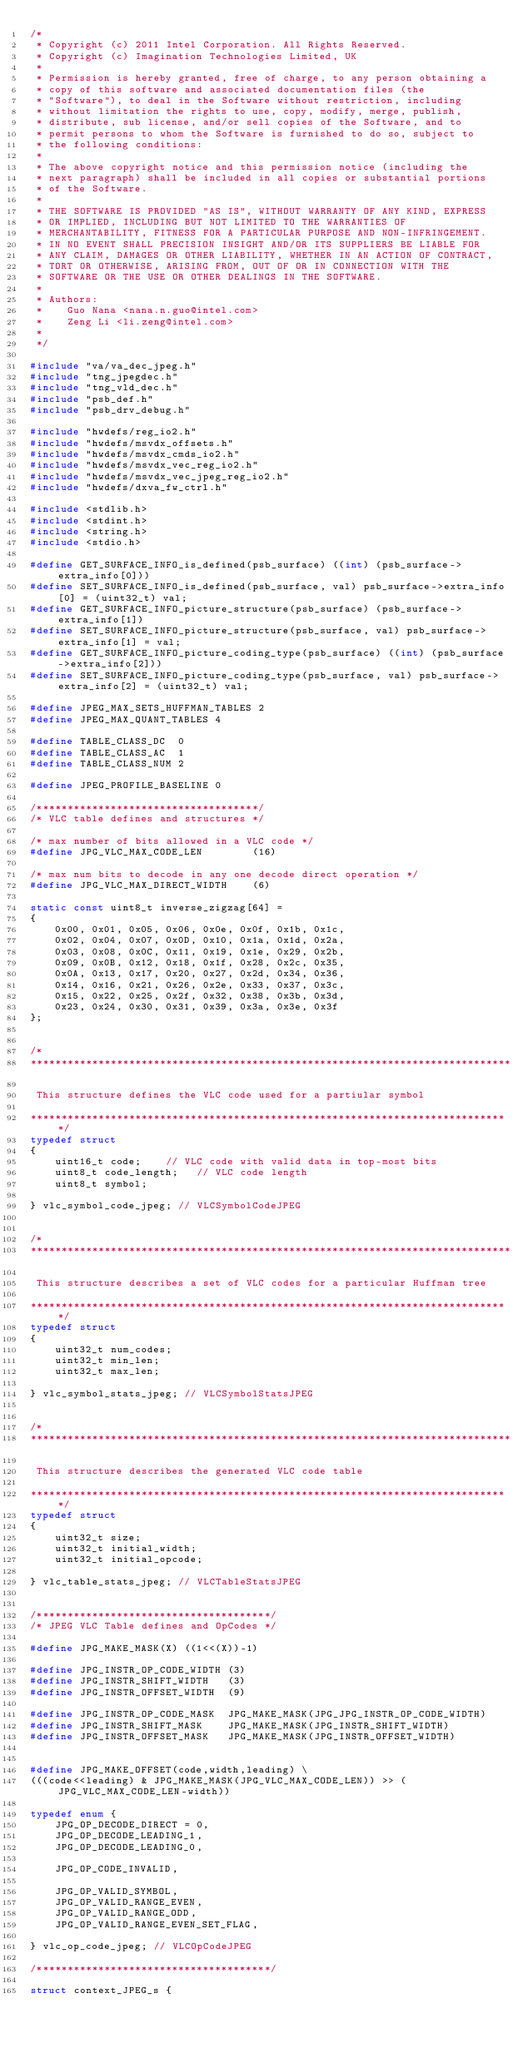Convert code to text. <code><loc_0><loc_0><loc_500><loc_500><_C_>/*
 * Copyright (c) 2011 Intel Corporation. All Rights Reserved.
 * Copyright (c) Imagination Technologies Limited, UK
 *
 * Permission is hereby granted, free of charge, to any person obtaining a
 * copy of this software and associated documentation files (the
 * "Software"), to deal in the Software without restriction, including
 * without limitation the rights to use, copy, modify, merge, publish,
 * distribute, sub license, and/or sell copies of the Software, and to
 * permit persons to whom the Software is furnished to do so, subject to
 * the following conditions:
 *
 * The above copyright notice and this permission notice (including the
 * next paragraph) shall be included in all copies or substantial portions
 * of the Software.
 *
 * THE SOFTWARE IS PROVIDED "AS IS", WITHOUT WARRANTY OF ANY KIND, EXPRESS
 * OR IMPLIED, INCLUDING BUT NOT LIMITED TO THE WARRANTIES OF
 * MERCHANTABILITY, FITNESS FOR A PARTICULAR PURPOSE AND NON-INFRINGEMENT.
 * IN NO EVENT SHALL PRECISION INSIGHT AND/OR ITS SUPPLIERS BE LIABLE FOR
 * ANY CLAIM, DAMAGES OR OTHER LIABILITY, WHETHER IN AN ACTION OF CONTRACT,
 * TORT OR OTHERWISE, ARISING FROM, OUT OF OR IN CONNECTION WITH THE
 * SOFTWARE OR THE USE OR OTHER DEALINGS IN THE SOFTWARE.
 *
 * Authors:
 *    Guo Nana <nana.n.guo@intel.com>
 *    Zeng Li <li.zeng@intel.com>
 *
 */

#include "va/va_dec_jpeg.h"
#include "tng_jpegdec.h"
#include "tng_vld_dec.h"
#include "psb_def.h"
#include "psb_drv_debug.h"

#include "hwdefs/reg_io2.h"
#include "hwdefs/msvdx_offsets.h"
#include "hwdefs/msvdx_cmds_io2.h"
#include "hwdefs/msvdx_vec_reg_io2.h"
#include "hwdefs/msvdx_vec_jpeg_reg_io2.h"
#include "hwdefs/dxva_fw_ctrl.h"

#include <stdlib.h>
#include <stdint.h>
#include <string.h>
#include <stdio.h>

#define GET_SURFACE_INFO_is_defined(psb_surface) ((int) (psb_surface->extra_info[0]))
#define SET_SURFACE_INFO_is_defined(psb_surface, val) psb_surface->extra_info[0] = (uint32_t) val;
#define GET_SURFACE_INFO_picture_structure(psb_surface) (psb_surface->extra_info[1])
#define SET_SURFACE_INFO_picture_structure(psb_surface, val) psb_surface->extra_info[1] = val;
#define GET_SURFACE_INFO_picture_coding_type(psb_surface) ((int) (psb_surface->extra_info[2]))
#define SET_SURFACE_INFO_picture_coding_type(psb_surface, val) psb_surface->extra_info[2] = (uint32_t) val;

#define JPEG_MAX_SETS_HUFFMAN_TABLES 2
#define JPEG_MAX_QUANT_TABLES 4

#define TABLE_CLASS_DC  0
#define TABLE_CLASS_AC  1
#define TABLE_CLASS_NUM 2

#define JPEG_PROFILE_BASELINE 0

/************************************/
/* VLC table defines and structures */

/* max number of bits allowed in a VLC code */
#define JPG_VLC_MAX_CODE_LEN        (16)

/* max num bits to decode in any one decode direct operation */
#define JPG_VLC_MAX_DIRECT_WIDTH    (6)

static const uint8_t inverse_zigzag[64] =
{
    0x00, 0x01, 0x05, 0x06, 0x0e, 0x0f, 0x1b, 0x1c,
    0x02, 0x04, 0x07, 0x0D, 0x10, 0x1a, 0x1d, 0x2a,
    0x03, 0x08, 0x0C, 0x11, 0x19, 0x1e, 0x29, 0x2b,
    0x09, 0x0B, 0x12, 0x18, 0x1f, 0x28, 0x2c, 0x35,
    0x0A, 0x13, 0x17, 0x20, 0x27, 0x2d, 0x34, 0x36,
    0x14, 0x16, 0x21, 0x26, 0x2e, 0x33, 0x37, 0x3c,
    0x15, 0x22, 0x25, 0x2f, 0x32, 0x38, 0x3b, 0x3d,
    0x23, 0x24, 0x30, 0x31, 0x39, 0x3a, 0x3e, 0x3f
};


/*
******************************************************************************

 This structure defines the VLC code used for a partiular symbol

******************************************************************************/
typedef struct
{
    uint16_t code;    // VLC code with valid data in top-most bits
    uint8_t code_length;   // VLC code length
    uint8_t symbol;

} vlc_symbol_code_jpeg; // VLCSymbolCodeJPEG


/*
******************************************************************************

 This structure describes a set of VLC codes for a particular Huffman tree

******************************************************************************/
typedef struct
{
    uint32_t num_codes;
    uint32_t min_len;
    uint32_t max_len;

} vlc_symbol_stats_jpeg; // VLCSymbolStatsJPEG


/*
******************************************************************************

 This structure describes the generated VLC code table

******************************************************************************/
typedef struct
{
    uint32_t size;
    uint32_t initial_width;
    uint32_t initial_opcode;

} vlc_table_stats_jpeg; // VLCTableStatsJPEG


/**************************************/
/* JPEG VLC Table defines and OpCodes */

#define JPG_MAKE_MASK(X) ((1<<(X))-1)

#define JPG_INSTR_OP_CODE_WIDTH (3)
#define JPG_INSTR_SHIFT_WIDTH   (3)
#define JPG_INSTR_OFFSET_WIDTH  (9)

#define JPG_INSTR_OP_CODE_MASK  JPG_MAKE_MASK(JPG_JPG_INSTR_OP_CODE_WIDTH)
#define JPG_INSTR_SHIFT_MASK    JPG_MAKE_MASK(JPG_INSTR_SHIFT_WIDTH)
#define JPG_INSTR_OFFSET_MASK   JPG_MAKE_MASK(JPG_INSTR_OFFSET_WIDTH)


#define JPG_MAKE_OFFSET(code,width,leading) \
(((code<<leading) & JPG_MAKE_MASK(JPG_VLC_MAX_CODE_LEN)) >> (JPG_VLC_MAX_CODE_LEN-width))

typedef enum {
    JPG_OP_DECODE_DIRECT = 0,
    JPG_OP_DECODE_LEADING_1,
    JPG_OP_DECODE_LEADING_0,

    JPG_OP_CODE_INVALID,

    JPG_OP_VALID_SYMBOL,
    JPG_OP_VALID_RANGE_EVEN,
    JPG_OP_VALID_RANGE_ODD,
    JPG_OP_VALID_RANGE_EVEN_SET_FLAG,

} vlc_op_code_jpeg; // VLCOpCodeJPEG

/**************************************/

struct context_JPEG_s {</code> 